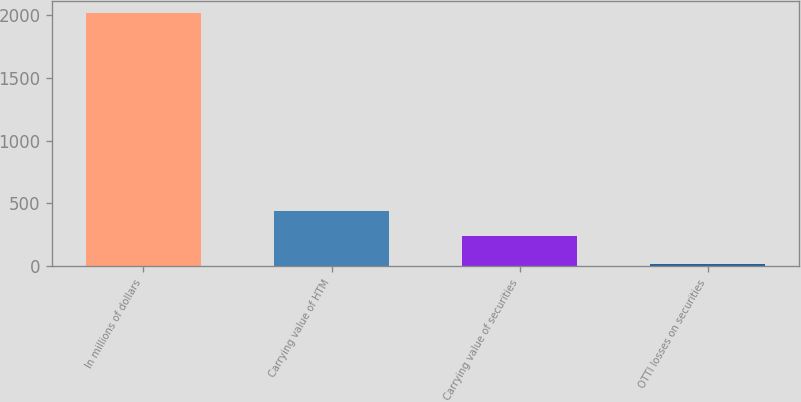<chart> <loc_0><loc_0><loc_500><loc_500><bar_chart><fcel>In millions of dollars<fcel>Carrying value of HTM<fcel>Carrying value of securities<fcel>OTTI losses on securities<nl><fcel>2015<fcel>443<fcel>243<fcel>15<nl></chart> 